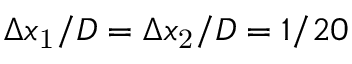Convert formula to latex. <formula><loc_0><loc_0><loc_500><loc_500>\Delta x _ { 1 } / D = \Delta x _ { 2 } / D = 1 / 2 0</formula> 